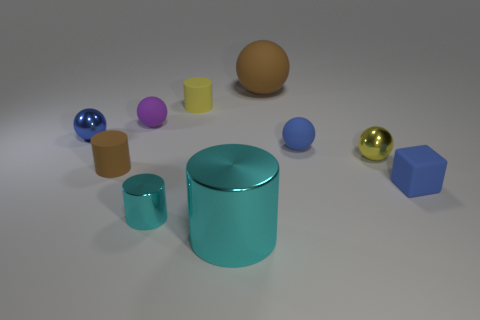There is a big metal thing; does it have the same shape as the big thing that is behind the purple thing?
Provide a succinct answer. No. The tiny rubber object that is the same color as the matte cube is what shape?
Ensure brevity in your answer.  Sphere. Is there a purple thing that has the same material as the small brown cylinder?
Give a very brief answer. Yes. What material is the large thing in front of the tiny metal thing on the right side of the small cyan object?
Ensure brevity in your answer.  Metal. There is a brown object right of the big object that is in front of the brown matte thing on the right side of the big metallic object; what size is it?
Ensure brevity in your answer.  Large. How many other objects are there of the same shape as the tiny brown rubber object?
Provide a short and direct response. 3. There is a small rubber cylinder that is behind the tiny yellow sphere; is it the same color as the tiny shiny sphere that is in front of the tiny blue metal object?
Your response must be concise. Yes. The shiny cylinder that is the same size as the brown ball is what color?
Provide a short and direct response. Cyan. Are there any tiny matte cylinders of the same color as the large matte ball?
Offer a very short reply. Yes. Does the yellow object that is in front of the purple matte object have the same size as the large rubber sphere?
Give a very brief answer. No. 